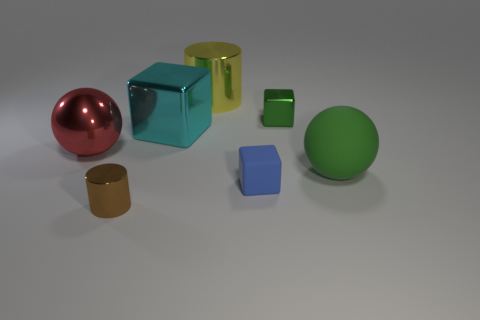Subtract all green metal blocks. How many blocks are left? 2 Add 3 purple metal balls. How many objects exist? 10 Subtract all blocks. How many objects are left? 4 Subtract all tiny cubes. Subtract all red balls. How many objects are left? 4 Add 4 large shiny cylinders. How many large shiny cylinders are left? 5 Add 5 small matte objects. How many small matte objects exist? 6 Subtract 1 yellow cylinders. How many objects are left? 6 